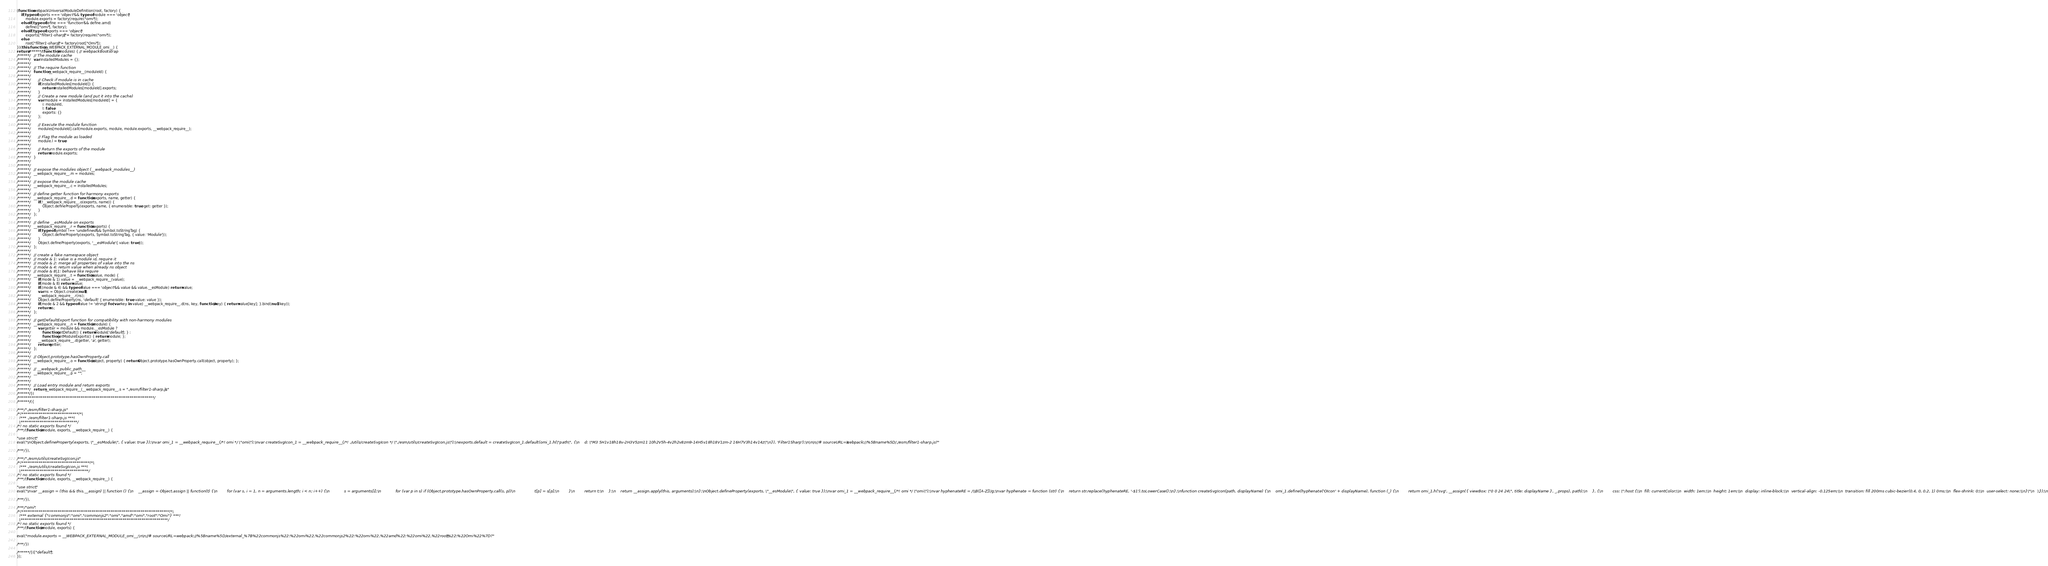<code> <loc_0><loc_0><loc_500><loc_500><_JavaScript_>(function webpackUniversalModuleDefinition(root, factory) {
	if(typeof exports === 'object' && typeof module === 'object')
		module.exports = factory(require("omi"));
	else if(typeof define === 'function' && define.amd)
		define(["omi"], factory);
	else if(typeof exports === 'object')
		exports["filter1-sharp"] = factory(require("omi"));
	else
		root["filter1-sharp"] = factory(root["Omi"]);
})(this, function(__WEBPACK_EXTERNAL_MODULE_omi__) {
return /******/ (function(modules) { // webpackBootstrap
/******/ 	// The module cache
/******/ 	var installedModules = {};
/******/
/******/ 	// The require function
/******/ 	function __webpack_require__(moduleId) {
/******/
/******/ 		// Check if module is in cache
/******/ 		if(installedModules[moduleId]) {
/******/ 			return installedModules[moduleId].exports;
/******/ 		}
/******/ 		// Create a new module (and put it into the cache)
/******/ 		var module = installedModules[moduleId] = {
/******/ 			i: moduleId,
/******/ 			l: false,
/******/ 			exports: {}
/******/ 		};
/******/
/******/ 		// Execute the module function
/******/ 		modules[moduleId].call(module.exports, module, module.exports, __webpack_require__);
/******/
/******/ 		// Flag the module as loaded
/******/ 		module.l = true;
/******/
/******/ 		// Return the exports of the module
/******/ 		return module.exports;
/******/ 	}
/******/
/******/
/******/ 	// expose the modules object (__webpack_modules__)
/******/ 	__webpack_require__.m = modules;
/******/
/******/ 	// expose the module cache
/******/ 	__webpack_require__.c = installedModules;
/******/
/******/ 	// define getter function for harmony exports
/******/ 	__webpack_require__.d = function(exports, name, getter) {
/******/ 		if(!__webpack_require__.o(exports, name)) {
/******/ 			Object.defineProperty(exports, name, { enumerable: true, get: getter });
/******/ 		}
/******/ 	};
/******/
/******/ 	// define __esModule on exports
/******/ 	__webpack_require__.r = function(exports) {
/******/ 		if(typeof Symbol !== 'undefined' && Symbol.toStringTag) {
/******/ 			Object.defineProperty(exports, Symbol.toStringTag, { value: 'Module' });
/******/ 		}
/******/ 		Object.defineProperty(exports, '__esModule', { value: true });
/******/ 	};
/******/
/******/ 	// create a fake namespace object
/******/ 	// mode & 1: value is a module id, require it
/******/ 	// mode & 2: merge all properties of value into the ns
/******/ 	// mode & 4: return value when already ns object
/******/ 	// mode & 8|1: behave like require
/******/ 	__webpack_require__.t = function(value, mode) {
/******/ 		if(mode & 1) value = __webpack_require__(value);
/******/ 		if(mode & 8) return value;
/******/ 		if((mode & 4) && typeof value === 'object' && value && value.__esModule) return value;
/******/ 		var ns = Object.create(null);
/******/ 		__webpack_require__.r(ns);
/******/ 		Object.defineProperty(ns, 'default', { enumerable: true, value: value });
/******/ 		if(mode & 2 && typeof value != 'string') for(var key in value) __webpack_require__.d(ns, key, function(key) { return value[key]; }.bind(null, key));
/******/ 		return ns;
/******/ 	};
/******/
/******/ 	// getDefaultExport function for compatibility with non-harmony modules
/******/ 	__webpack_require__.n = function(module) {
/******/ 		var getter = module && module.__esModule ?
/******/ 			function getDefault() { return module['default']; } :
/******/ 			function getModuleExports() { return module; };
/******/ 		__webpack_require__.d(getter, 'a', getter);
/******/ 		return getter;
/******/ 	};
/******/
/******/ 	// Object.prototype.hasOwnProperty.call
/******/ 	__webpack_require__.o = function(object, property) { return Object.prototype.hasOwnProperty.call(object, property); };
/******/
/******/ 	// __webpack_public_path__
/******/ 	__webpack_require__.p = "";
/******/
/******/
/******/ 	// Load entry module and return exports
/******/ 	return __webpack_require__(__webpack_require__.s = "./esm/filter1-sharp.js");
/******/ })
/************************************************************************/
/******/ ({

/***/ "./esm/filter1-sharp.js":
/*!******************************!*\
  !*** ./esm/filter1-sharp.js ***!
  \******************************/
/*! no static exports found */
/***/ (function(module, exports, __webpack_require__) {

"use strict";
eval("\nObject.defineProperty(exports, \"__esModule\", { value: true });\nvar omi_1 = __webpack_require__(/*! omi */ \"omi\");\nvar createSvgIcon_1 = __webpack_require__(/*! ./utils/createSvgIcon */ \"./esm/utils/createSvgIcon.js\");\nexports.default = createSvgIcon_1.default(omi_1.h(\"path\", {\n    d: \"M3 5H1v18h18v-2H3V5zm11 10h2V5h-4v2h2v8zm9-14H5v18h18V1zm-2 16H7V3h14v14z\"\n}), 'Filter1Sharp');\n\n\n//# sourceURL=webpack://%5Bname%5D/./esm/filter1-sharp.js?");

/***/ }),

/***/ "./esm/utils/createSvgIcon.js":
/*!************************************!*\
  !*** ./esm/utils/createSvgIcon.js ***!
  \************************************/
/*! no static exports found */
/***/ (function(module, exports, __webpack_require__) {

"use strict";
eval("\nvar __assign = (this && this.__assign) || function () {\n    __assign = Object.assign || function(t) {\n        for (var s, i = 1, n = arguments.length; i < n; i++) {\n            s = arguments[i];\n            for (var p in s) if (Object.prototype.hasOwnProperty.call(s, p))\n                t[p] = s[p];\n        }\n        return t;\n    };\n    return __assign.apply(this, arguments);\n};\nObject.defineProperty(exports, \"__esModule\", { value: true });\nvar omi_1 = __webpack_require__(/*! omi */ \"omi\");\nvar hyphenateRE = /\\B([A-Z])/g;\nvar hyphenate = function (str) {\n    return str.replace(hyphenateRE, '-$1').toLowerCase();\n};\nfunction createSvgIcon(path, displayName) {\n    omi_1.define(hyphenate('OIcon' + displayName), function (_) {\n        return omi_1.h('svg', __assign({ viewBox: \"0 0 24 24\", title: displayName }, _.props), path);\n    }, {\n        css: \":host {\\n  fill: currentColor;\\n  width: 1em;\\n  height: 1em;\\n  display: inline-block;\\n  vertical-align: -0.125em;\\n  transition: fill 200ms cubic-bezier(0.4, 0, 0.2, 1) 0ms;\\n  flex-shrink: 0;\\n  user-select: none;\\n}\"\n    });\n}\nexports.default = createSvgIcon;\n\n\n//# sourceURL=webpack://%5Bname%5D/./esm/utils/createSvgIcon.js?");

/***/ }),

/***/ "omi":
/*!******************************************************************************!*\
  !*** external {"commonjs":"omi","commonjs2":"omi","amd":"omi","root":"Omi"} ***!
  \******************************************************************************/
/*! no static exports found */
/***/ (function(module, exports) {

eval("module.exports = __WEBPACK_EXTERNAL_MODULE_omi__;\n\n//# sourceURL=webpack://%5Bname%5D/external_%7B%22commonjs%22:%22omi%22,%22commonjs2%22:%22omi%22,%22amd%22:%22omi%22,%22root%22:%22Omi%22%7D?");

/***/ })

/******/ })["default"];
});</code> 